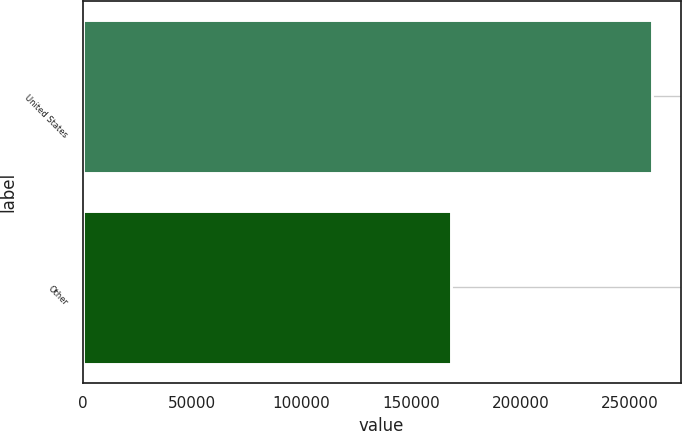<chart> <loc_0><loc_0><loc_500><loc_500><bar_chart><fcel>United States<fcel>Other<nl><fcel>260247<fcel>168569<nl></chart> 